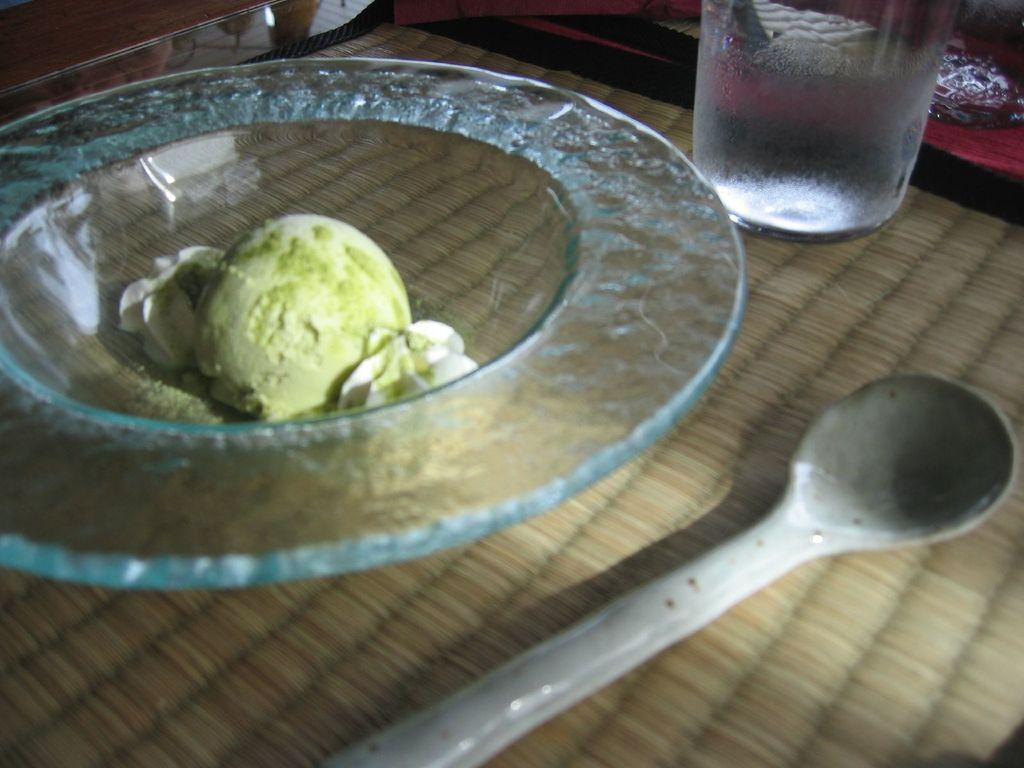What type of utensil is visible in the image? There is a spoon in the image. What is the spoon placed in? There is a bowl in the image. What other object is present on the table? There is a glass in the image. Where are these objects located? All these objects are on a table. What type of note is being passed around the fire in the image? There is no note or fire present in the image; it only features a spoon, bowl, and glass on a table. 